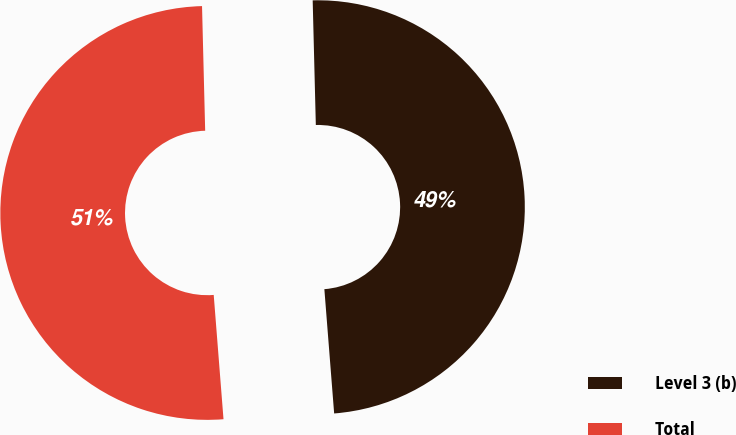Convert chart to OTSL. <chart><loc_0><loc_0><loc_500><loc_500><pie_chart><fcel>Level 3 (b)<fcel>Total<nl><fcel>49.15%<fcel>50.85%<nl></chart> 